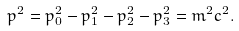<formula> <loc_0><loc_0><loc_500><loc_500>p ^ { 2 } = p _ { 0 } ^ { 2 } - p _ { 1 } ^ { 2 } - p _ { 2 } ^ { 2 } - p _ { 3 } ^ { 2 } = m ^ { 2 } c ^ { 2 } .</formula> 